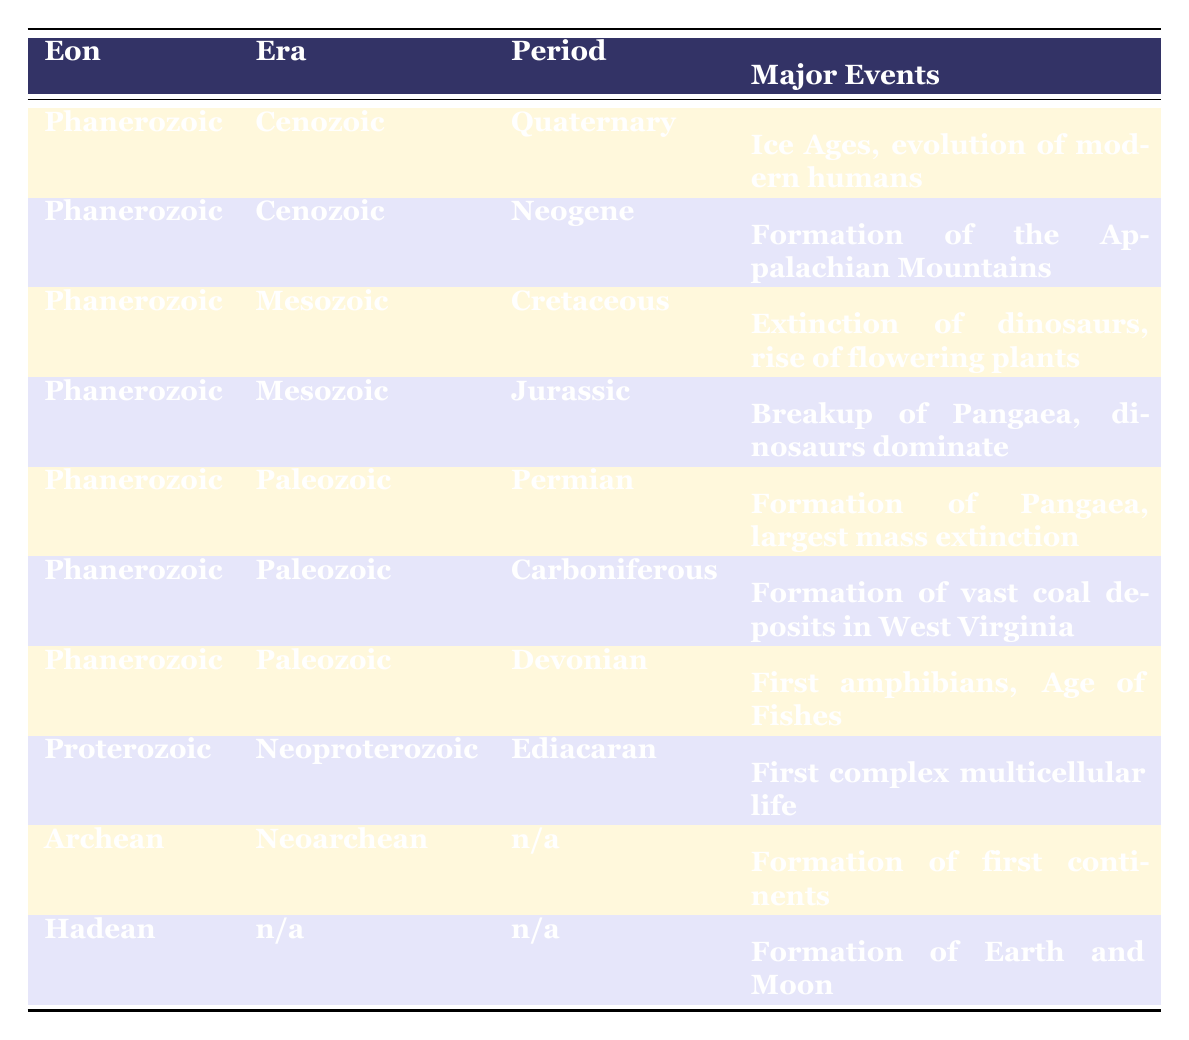What major event occurred during the Carboniferous period? According to the table, during the Carboniferous period, the major event was the formation of vast coal deposits in West Virginia.
Answer: Formation of vast coal deposits in West Virginia Which era includes the Jurassic period? The table indicates that the Jurassic period is part of the Mesozoic era.
Answer: Mesozoic Is the first complex multicellular life associated with the Neoproterozoic eon? The table shows that the Ediacaran period, which is in the Neoproterozoic eon, is linked to the first complex multicellular life. Therefore, the statement is true.
Answer: Yes How many major events are listed for the Paleozoic era? Looking at the table, the Paleozoic era is represented by three periods: Permian, Carboniferous, and Devonian, each with one major event. So, there are three major events listed.
Answer: Three What major event marks the end of the Cretaceous period? The table indicates that the Cretaceous period is characterized by the extinction of dinosaurs and the rise of flowering plants. However, since we are asked about the end of the period, the extinction of dinosaurs is the primary event.
Answer: Extinction of dinosaurs Which eon precedes the Phanerozoic? According to the table, the eon that comes before the Phanerozoic is the Proterozoic.
Answer: Proterozoic Overall, how many periods are there in the Phanerozoic eon? The table identifies six periods in the Phanerozoic eon: Quaternary, Neogene, Cretaceous, Jurassic, Permian, Carboniferous, and Devonian. Counting them gives a total of six periods.
Answer: Six During which period did the breakup of Pangaea occur? Based on the table, the breakup of Pangaea is noted as a major event during the Jurassic period.
Answer: Jurassic Does any period in the table have a 'n/a' designation for major events? The table indicates that both the Neoarchean era and Hadean eon have 'n/a' for the periods and major events. Thus, the statement is true.
Answer: Yes 